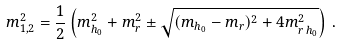Convert formula to latex. <formula><loc_0><loc_0><loc_500><loc_500>m ^ { 2 } _ { 1 , 2 } = \frac { 1 } { 2 } \left ( m _ { h _ { 0 } } ^ { 2 } + m _ { r } ^ { 2 } \pm \sqrt { ( m _ { h _ { 0 } } - m _ { r } ) ^ { 2 } + 4 m _ { r \, h _ { 0 } } ^ { 2 } } \right ) \, .</formula> 